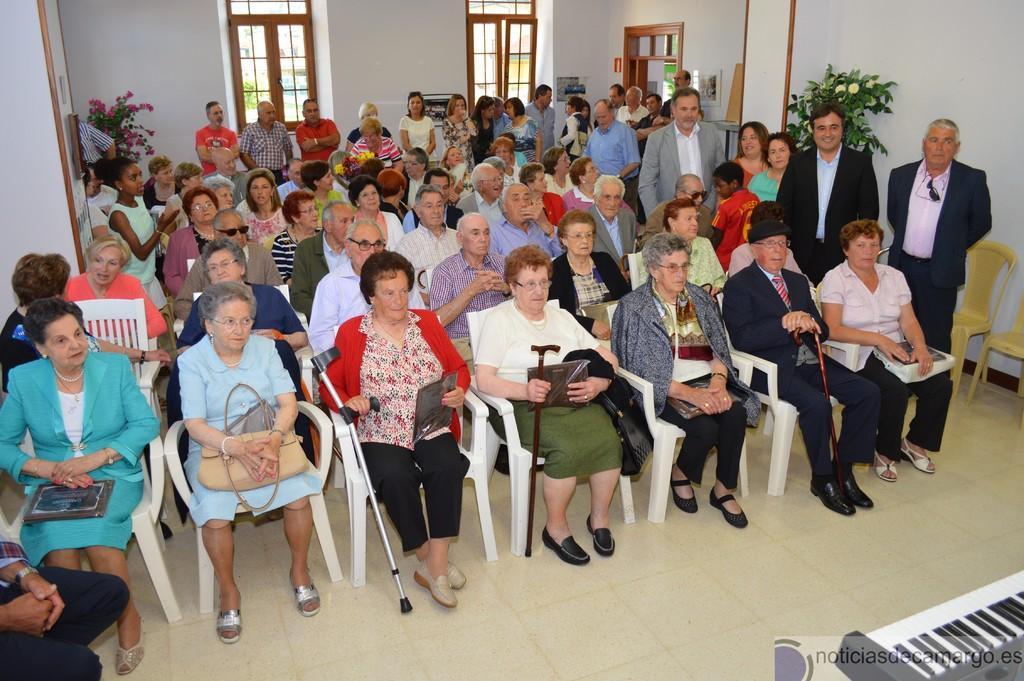Can you describe this image briefly? In this image we can see a group of people are sitting on the chairs, here is the glass window, here is the door, here is the plant, and flowers on it, here is the piano, here is the wall. 